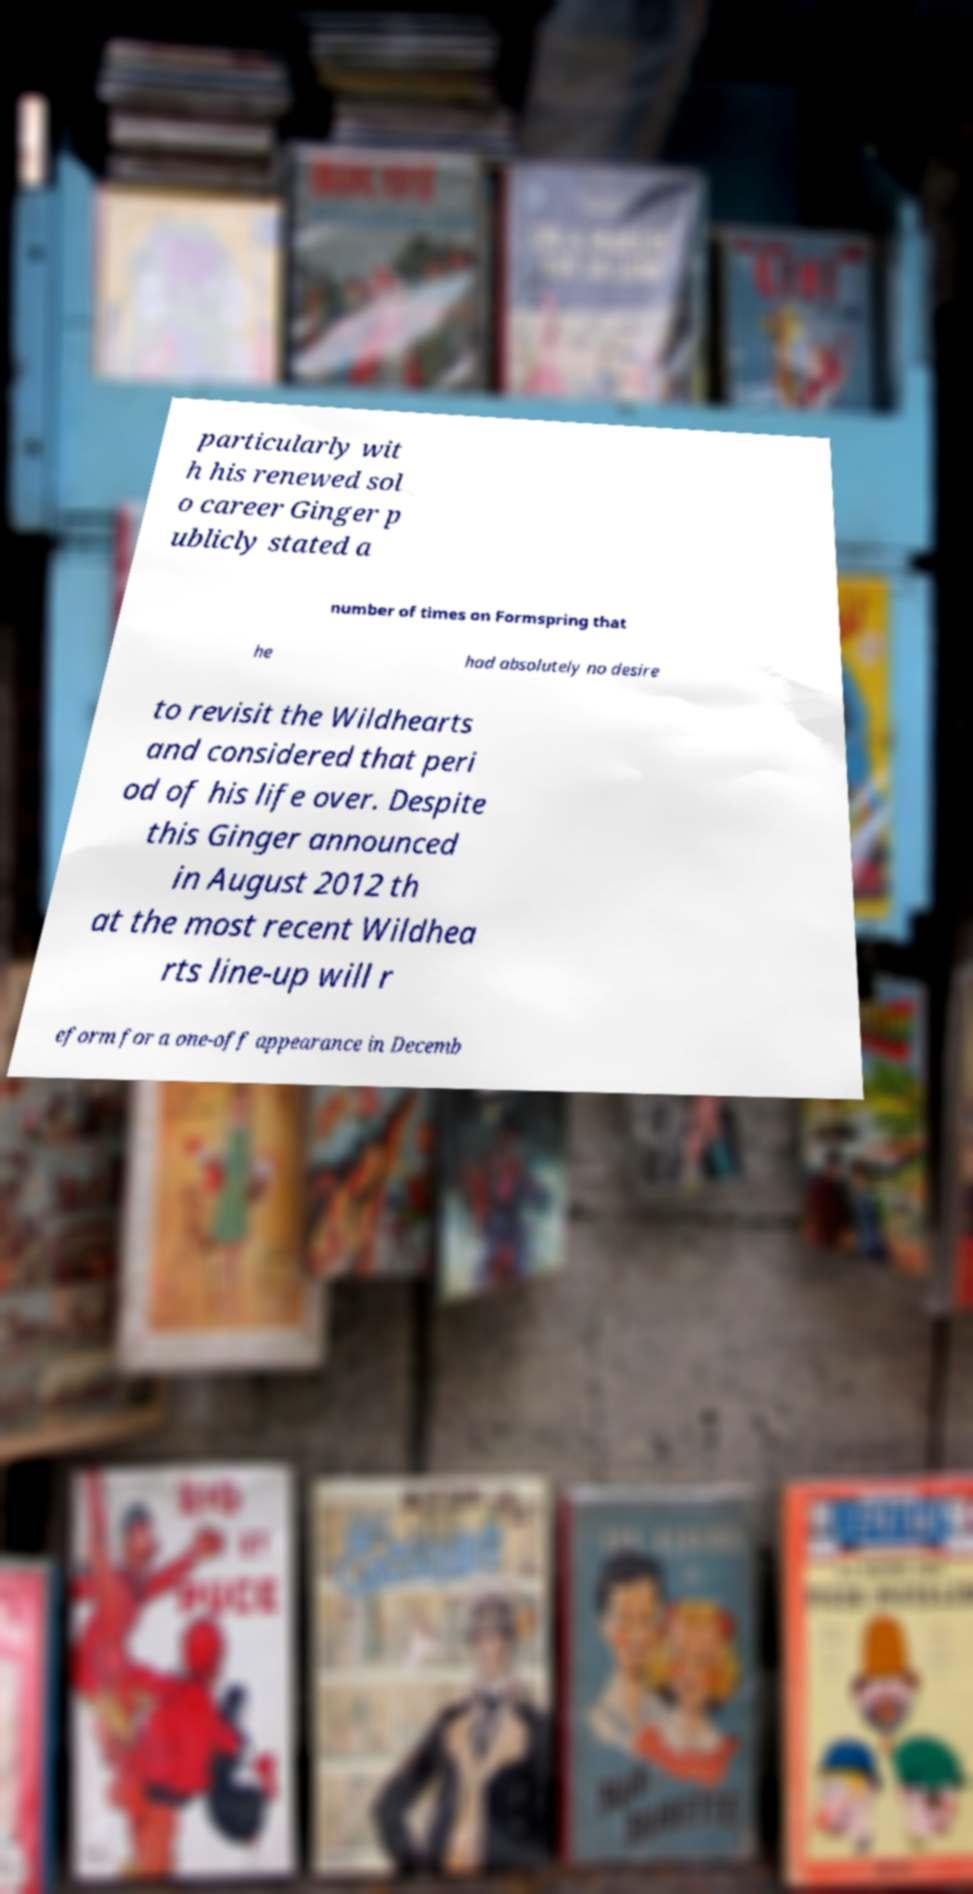For documentation purposes, I need the text within this image transcribed. Could you provide that? particularly wit h his renewed sol o career Ginger p ublicly stated a number of times on Formspring that he had absolutely no desire to revisit the Wildhearts and considered that peri od of his life over. Despite this Ginger announced in August 2012 th at the most recent Wildhea rts line-up will r eform for a one-off appearance in Decemb 